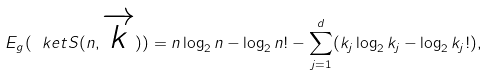Convert formula to latex. <formula><loc_0><loc_0><loc_500><loc_500>E _ { g } ( \ k e t { S ( n , \overrightarrow { k } ) } ) = n \log _ { 2 } n - \log _ { 2 } n ! - \sum _ { j = 1 } ^ { d } ( k _ { j } \log _ { 2 } k _ { j } - \log _ { 2 } k _ { j } ! ) ,</formula> 